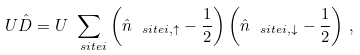Convert formula to latex. <formula><loc_0><loc_0><loc_500><loc_500>U \hat { D } = U \sum _ { \ s i t e i } \left ( \hat { n } _ { \ s i t e i , \uparrow } - \frac { 1 } { 2 } \right ) \left ( \hat { n } _ { \ s i t e i , \downarrow } - \frac { 1 } { 2 } \right ) \, ,</formula> 